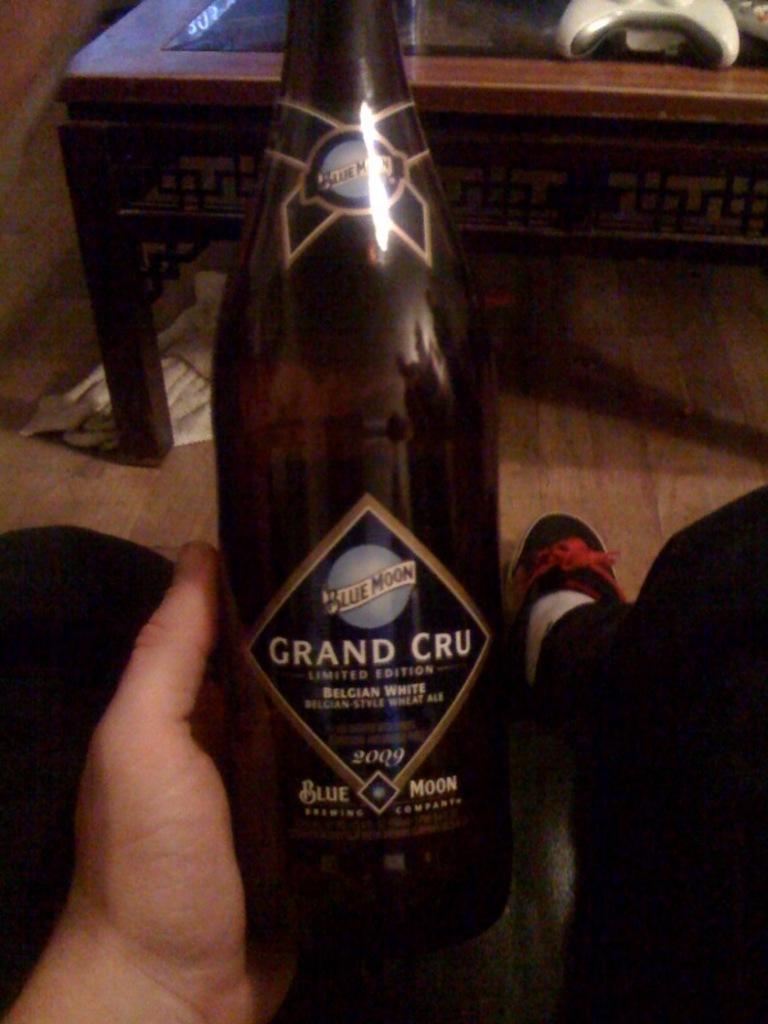What is the brand and flavor of beer?
Keep it short and to the point. Blue moon grand cru. What year is the beer from?
Your answer should be compact. 2009. 